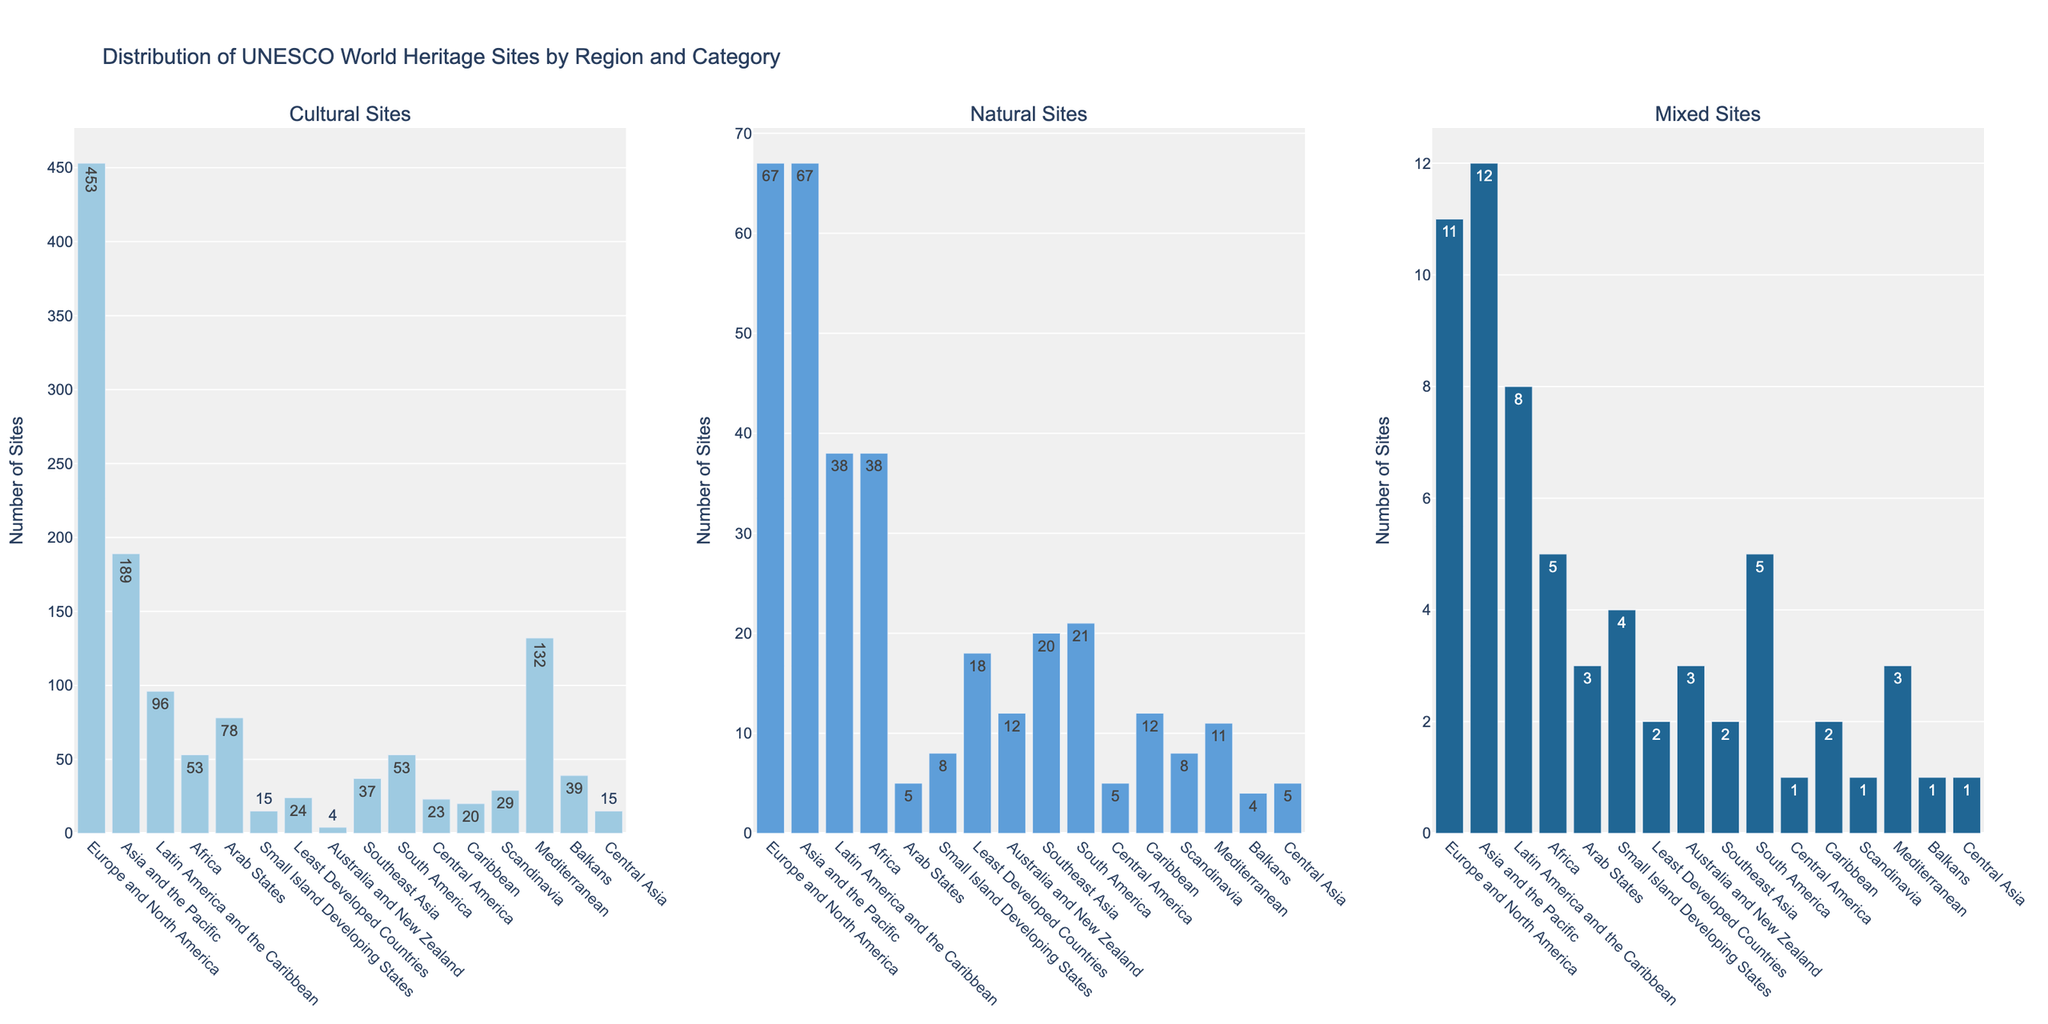Which region has the highest number of cultural sites? Looking at the bar chart for Cultural Sites, the tallest bar represents Europe and North America.
Answer: Europe and North America Which region has more natural sites: Latin America and the Caribbean or Southeast Asia? Comparing the bars for Natural Sites in both regions, Latin America and the Caribbean has 38 sites, while Southeast Asia has 20 sites.
Answer: Latin America and the Caribbean How many total sites are there in Africa across all categories? Sum the number of cultural, natural, and mixed sites for Africa: 53 (Cultural) + 38 (Natural) + 5 (Mixed) = 96.
Answer: 96 Are there more mixed sites in the Caribbean or Central Asia? Comparing the Mixed Sites bars, the Caribbean has 2, and Central Asia has 1.
Answer: Caribbean What is the combined number of cultural and natural sites in the Mediterranean? Sum the number of cultural and natural sites for the Mediterranean: 132 (Cultural) + 11 (Natural) = 143.
Answer: 143 Looking at natural sites, which region has a larger number: Europe and North America or Australia and New Zealand? Europe and North America has 67 natural sites, while Australia and New Zealand has 12.
Answer: Europe and North America Which region has the smallest number of cultural sites? The shortest bar in the Cultural Sites chart represents Australia and New Zealand with 4 sites.
Answer: Australia and New Zealand Is the number of mixed sites higher in Small Island Developing States or Southeast Asia? Comparing the Mixed Sites bars, Small Island Developing States has 4, and Southeast Asia has 2.
Answer: Small Island Developing States Which region has the third-highest number of cultural sites? By visually inspecting the heights of the bars, the third-highest is the Mediterranean with 132 cultural sites.
Answer: Mediterranean How many more cultural sites does Asia and the Pacific have compared to the Arab States? Subtract the number of cultural sites in the Arab States from Asia and the Pacific’s: 189 - 78 = 111.
Answer: 111 